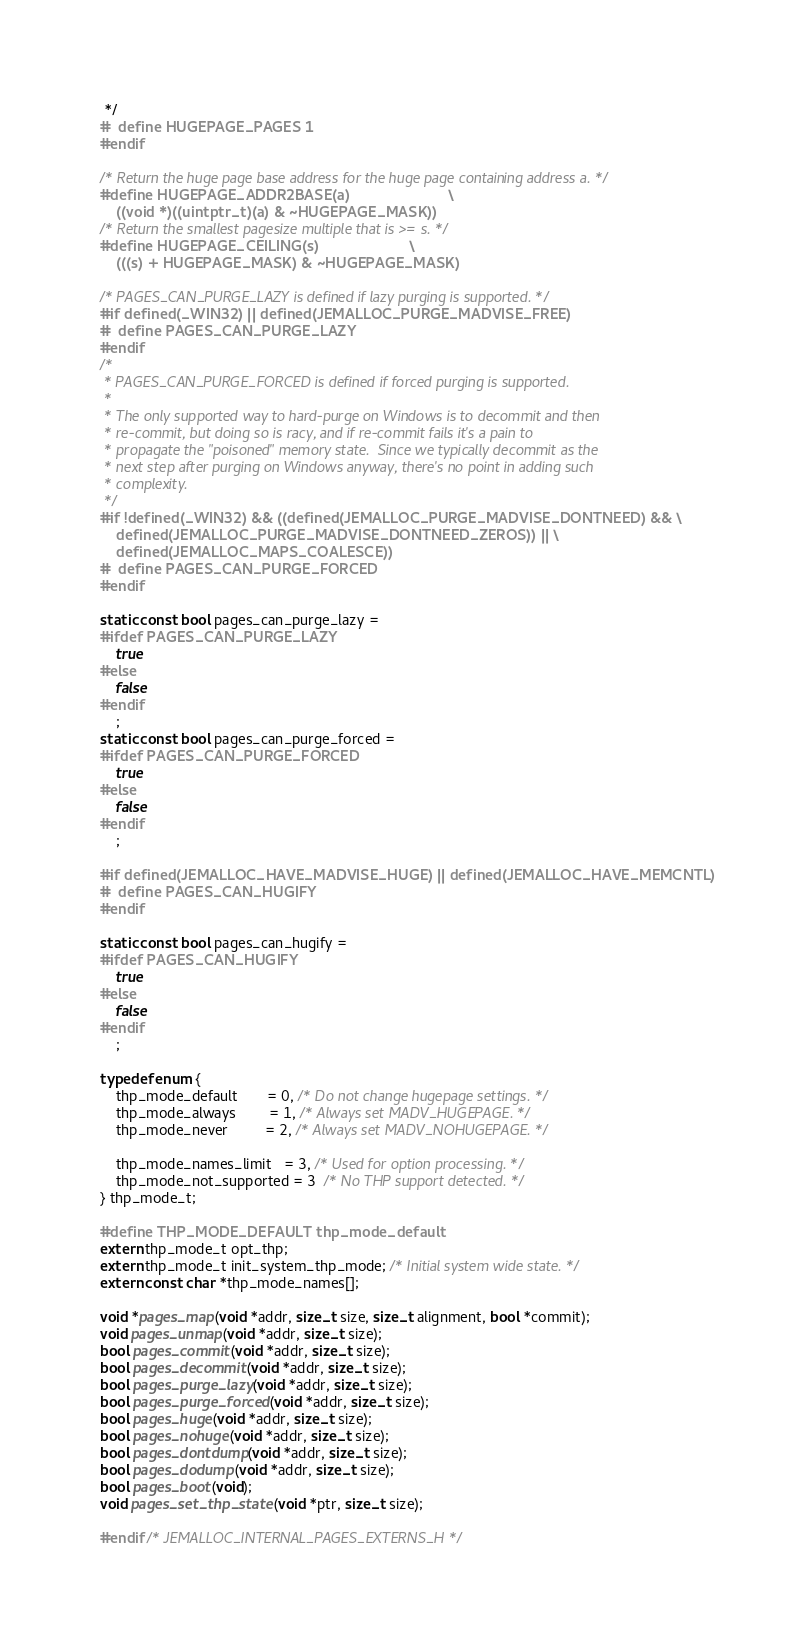Convert code to text. <code><loc_0><loc_0><loc_500><loc_500><_C_> */
#  define HUGEPAGE_PAGES 1
#endif

/* Return the huge page base address for the huge page containing address a. */
#define HUGEPAGE_ADDR2BASE(a)						\
	((void *)((uintptr_t)(a) & ~HUGEPAGE_MASK))
/* Return the smallest pagesize multiple that is >= s. */
#define HUGEPAGE_CEILING(s)						\
	(((s) + HUGEPAGE_MASK) & ~HUGEPAGE_MASK)

/* PAGES_CAN_PURGE_LAZY is defined if lazy purging is supported. */
#if defined(_WIN32) || defined(JEMALLOC_PURGE_MADVISE_FREE)
#  define PAGES_CAN_PURGE_LAZY
#endif
/*
 * PAGES_CAN_PURGE_FORCED is defined if forced purging is supported.
 *
 * The only supported way to hard-purge on Windows is to decommit and then
 * re-commit, but doing so is racy, and if re-commit fails it's a pain to
 * propagate the "poisoned" memory state.  Since we typically decommit as the
 * next step after purging on Windows anyway, there's no point in adding such
 * complexity.
 */
#if !defined(_WIN32) && ((defined(JEMALLOC_PURGE_MADVISE_DONTNEED) && \
    defined(JEMALLOC_PURGE_MADVISE_DONTNEED_ZEROS)) || \
    defined(JEMALLOC_MAPS_COALESCE))
#  define PAGES_CAN_PURGE_FORCED
#endif

static const bool pages_can_purge_lazy =
#ifdef PAGES_CAN_PURGE_LAZY
    true
#else
    false
#endif
    ;
static const bool pages_can_purge_forced =
#ifdef PAGES_CAN_PURGE_FORCED
    true
#else
    false
#endif
    ;

#if defined(JEMALLOC_HAVE_MADVISE_HUGE) || defined(JEMALLOC_HAVE_MEMCNTL)
#  define PAGES_CAN_HUGIFY
#endif

static const bool pages_can_hugify =
#ifdef PAGES_CAN_HUGIFY
    true
#else
    false
#endif
    ;

typedef enum {
	thp_mode_default       = 0, /* Do not change hugepage settings. */
	thp_mode_always        = 1, /* Always set MADV_HUGEPAGE. */
	thp_mode_never         = 2, /* Always set MADV_NOHUGEPAGE. */

	thp_mode_names_limit   = 3, /* Used for option processing. */
	thp_mode_not_supported = 3  /* No THP support detected. */
} thp_mode_t;

#define THP_MODE_DEFAULT thp_mode_default
extern thp_mode_t opt_thp;
extern thp_mode_t init_system_thp_mode; /* Initial system wide state. */
extern const char *thp_mode_names[];

void *pages_map(void *addr, size_t size, size_t alignment, bool *commit);
void pages_unmap(void *addr, size_t size);
bool pages_commit(void *addr, size_t size);
bool pages_decommit(void *addr, size_t size);
bool pages_purge_lazy(void *addr, size_t size);
bool pages_purge_forced(void *addr, size_t size);
bool pages_huge(void *addr, size_t size);
bool pages_nohuge(void *addr, size_t size);
bool pages_dontdump(void *addr, size_t size);
bool pages_dodump(void *addr, size_t size);
bool pages_boot(void);
void pages_set_thp_state (void *ptr, size_t size);

#endif /* JEMALLOC_INTERNAL_PAGES_EXTERNS_H */
</code> 